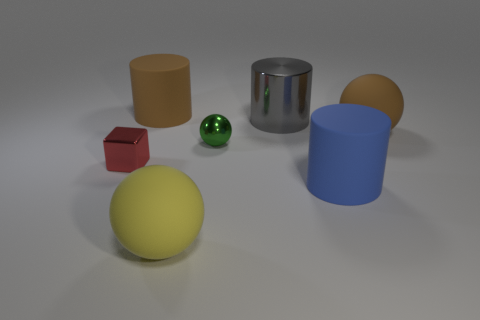There is a tiny green sphere; are there any objects to the left of it?
Ensure brevity in your answer.  Yes. Do the gray cylinder and the brown matte ball have the same size?
Make the answer very short. Yes. There is a big brown thing that is right of the tiny sphere; what is its shape?
Provide a succinct answer. Sphere. Are there any spheres of the same size as the brown cylinder?
Provide a short and direct response. Yes. What material is the brown thing that is the same size as the brown cylinder?
Your answer should be compact. Rubber. How big is the brown cylinder that is behind the green metal sphere?
Your answer should be very brief. Large. How big is the green ball?
Offer a terse response. Small. There is a yellow rubber ball; does it have the same size as the rubber cylinder that is behind the tiny red thing?
Your answer should be compact. Yes. The tiny shiny thing that is right of the rubber cylinder behind the big gray metal thing is what color?
Make the answer very short. Green. Are there the same number of things behind the small green sphere and green shiny balls that are in front of the large yellow matte ball?
Give a very brief answer. No. 